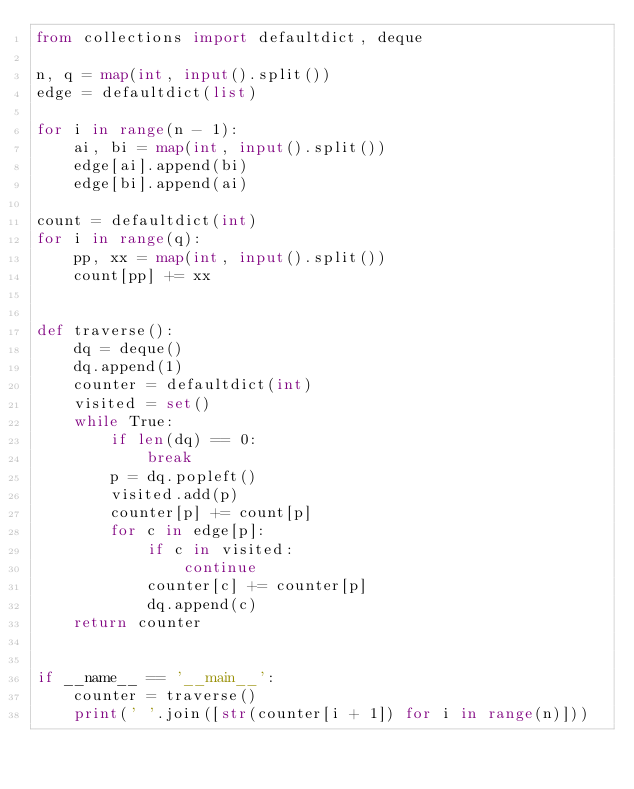<code> <loc_0><loc_0><loc_500><loc_500><_Python_>from collections import defaultdict, deque

n, q = map(int, input().split())
edge = defaultdict(list)

for i in range(n - 1):
    ai, bi = map(int, input().split())
    edge[ai].append(bi)
    edge[bi].append(ai)

count = defaultdict(int)
for i in range(q):
    pp, xx = map(int, input().split())
    count[pp] += xx


def traverse():
    dq = deque()
    dq.append(1)
    counter = defaultdict(int)
    visited = set()
    while True:
        if len(dq) == 0:
            break
        p = dq.popleft()
        visited.add(p)
        counter[p] += count[p]
        for c in edge[p]:
            if c in visited:
                continue
            counter[c] += counter[p]
            dq.append(c)
    return counter


if __name__ == '__main__':
    counter = traverse()
    print(' '.join([str(counter[i + 1]) for i in range(n)]))
</code> 